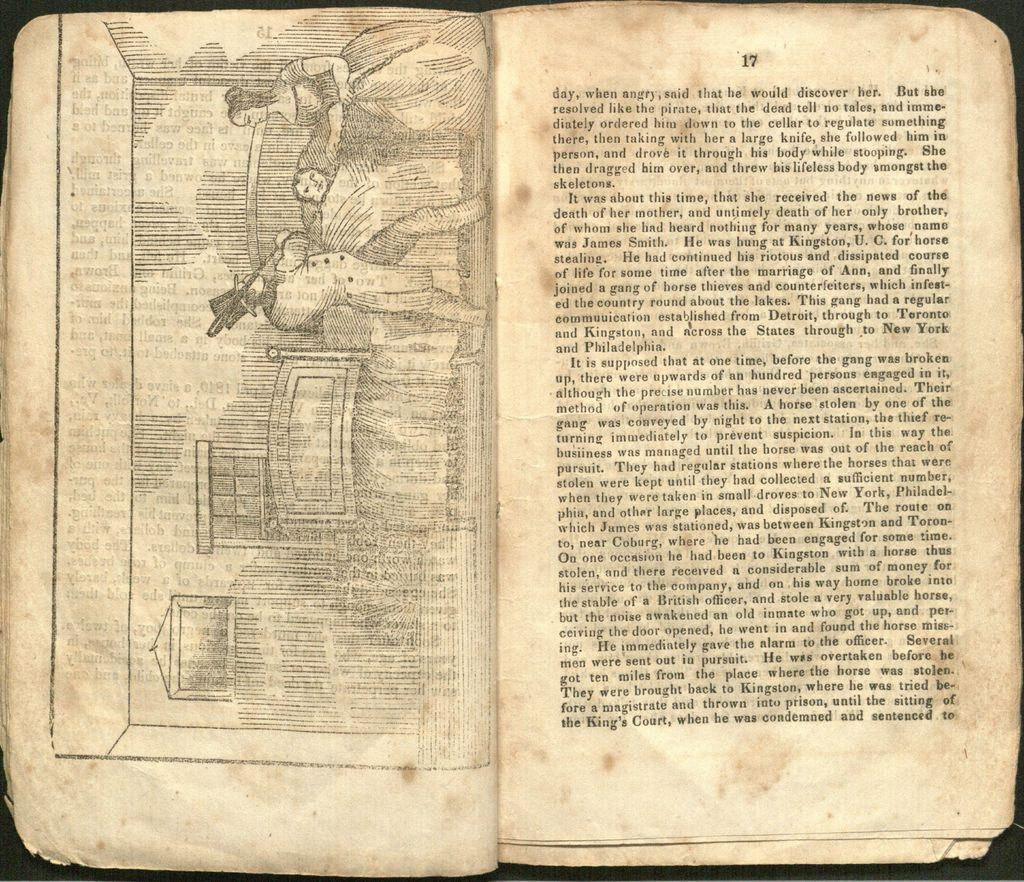<image>
Offer a succinct explanation of the picture presented. Old book opened up to page 17 written in old english. 